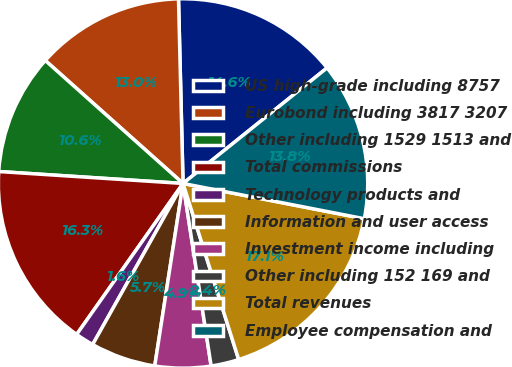Convert chart to OTSL. <chart><loc_0><loc_0><loc_500><loc_500><pie_chart><fcel>US high-grade including 8757<fcel>Eurobond including 3817 3207<fcel>Other including 1529 1513 and<fcel>Total commissions<fcel>Technology products and<fcel>Information and user access<fcel>Investment income including<fcel>Other including 152 169 and<fcel>Total revenues<fcel>Employee compensation and<nl><fcel>14.63%<fcel>13.01%<fcel>10.57%<fcel>16.26%<fcel>1.63%<fcel>5.69%<fcel>4.88%<fcel>2.44%<fcel>17.07%<fcel>13.82%<nl></chart> 